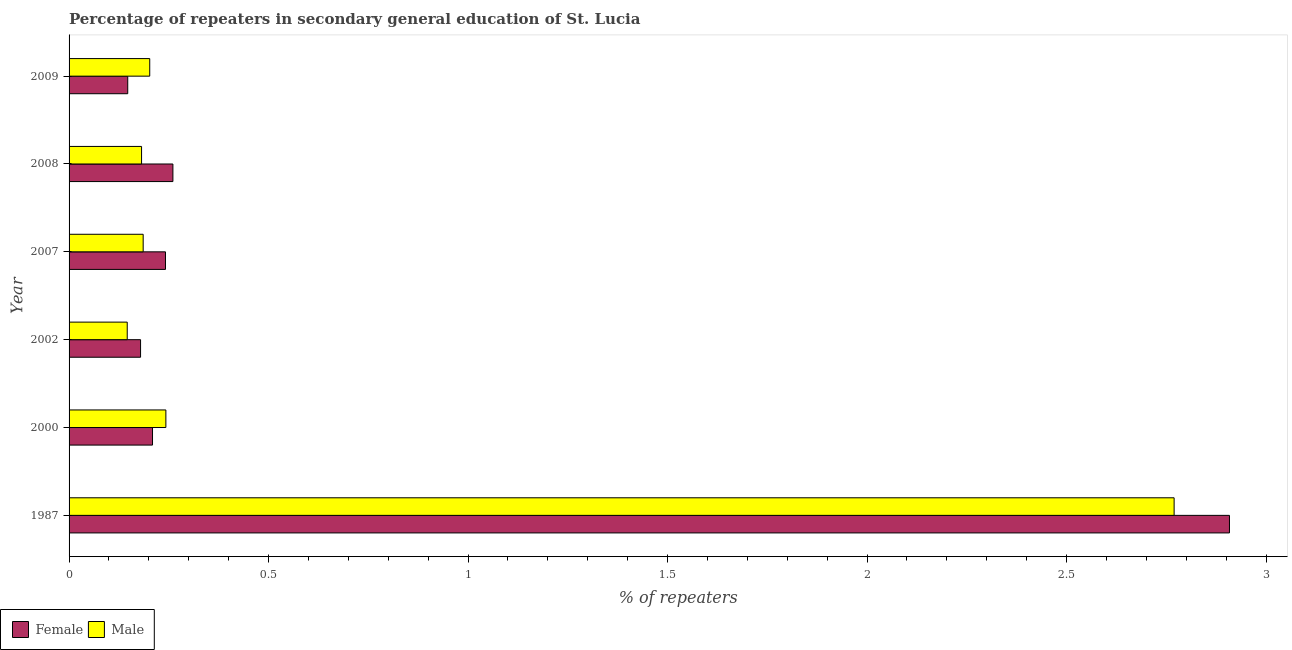How many bars are there on the 6th tick from the bottom?
Your answer should be very brief. 2. What is the percentage of female repeaters in 1987?
Your answer should be very brief. 2.91. Across all years, what is the maximum percentage of female repeaters?
Provide a short and direct response. 2.91. Across all years, what is the minimum percentage of male repeaters?
Offer a very short reply. 0.15. In which year was the percentage of female repeaters maximum?
Your response must be concise. 1987. What is the total percentage of male repeaters in the graph?
Your response must be concise. 3.73. What is the difference between the percentage of male repeaters in 1987 and that in 2000?
Provide a succinct answer. 2.53. What is the difference between the percentage of female repeaters in 2008 and the percentage of male repeaters in 2007?
Your answer should be compact. 0.07. What is the average percentage of male repeaters per year?
Give a very brief answer. 0.62. In the year 2002, what is the difference between the percentage of female repeaters and percentage of male repeaters?
Your response must be concise. 0.03. In how many years, is the percentage of male repeaters greater than 2.5 %?
Keep it short and to the point. 1. What is the ratio of the percentage of male repeaters in 1987 to that in 2007?
Ensure brevity in your answer.  14.91. Is the difference between the percentage of male repeaters in 2000 and 2002 greater than the difference between the percentage of female repeaters in 2000 and 2002?
Your response must be concise. Yes. What is the difference between the highest and the second highest percentage of male repeaters?
Offer a very short reply. 2.53. What is the difference between the highest and the lowest percentage of male repeaters?
Ensure brevity in your answer.  2.62. Is the sum of the percentage of female repeaters in 1987 and 2007 greater than the maximum percentage of male repeaters across all years?
Keep it short and to the point. Yes. What does the 2nd bar from the bottom in 2000 represents?
Your response must be concise. Male. Does the graph contain any zero values?
Give a very brief answer. No. Does the graph contain grids?
Your answer should be very brief. No. Where does the legend appear in the graph?
Make the answer very short. Bottom left. What is the title of the graph?
Your response must be concise. Percentage of repeaters in secondary general education of St. Lucia. Does "Ages 15-24" appear as one of the legend labels in the graph?
Provide a short and direct response. No. What is the label or title of the X-axis?
Your answer should be very brief. % of repeaters. What is the label or title of the Y-axis?
Make the answer very short. Year. What is the % of repeaters in Female in 1987?
Offer a very short reply. 2.91. What is the % of repeaters of Male in 1987?
Provide a succinct answer. 2.77. What is the % of repeaters of Female in 2000?
Provide a short and direct response. 0.21. What is the % of repeaters in Male in 2000?
Offer a terse response. 0.24. What is the % of repeaters of Female in 2002?
Make the answer very short. 0.18. What is the % of repeaters of Male in 2002?
Make the answer very short. 0.15. What is the % of repeaters in Female in 2007?
Provide a short and direct response. 0.24. What is the % of repeaters of Male in 2007?
Your answer should be very brief. 0.19. What is the % of repeaters of Female in 2008?
Your answer should be very brief. 0.26. What is the % of repeaters in Male in 2008?
Provide a succinct answer. 0.18. What is the % of repeaters in Female in 2009?
Offer a terse response. 0.15. What is the % of repeaters in Male in 2009?
Your response must be concise. 0.2. Across all years, what is the maximum % of repeaters of Female?
Your answer should be compact. 2.91. Across all years, what is the maximum % of repeaters in Male?
Provide a succinct answer. 2.77. Across all years, what is the minimum % of repeaters of Female?
Your response must be concise. 0.15. Across all years, what is the minimum % of repeaters of Male?
Keep it short and to the point. 0.15. What is the total % of repeaters of Female in the graph?
Your response must be concise. 3.95. What is the total % of repeaters of Male in the graph?
Give a very brief answer. 3.73. What is the difference between the % of repeaters in Female in 1987 and that in 2000?
Ensure brevity in your answer.  2.7. What is the difference between the % of repeaters of Male in 1987 and that in 2000?
Your response must be concise. 2.53. What is the difference between the % of repeaters in Female in 1987 and that in 2002?
Offer a very short reply. 2.73. What is the difference between the % of repeaters in Male in 1987 and that in 2002?
Offer a very short reply. 2.62. What is the difference between the % of repeaters of Female in 1987 and that in 2007?
Offer a terse response. 2.67. What is the difference between the % of repeaters in Male in 1987 and that in 2007?
Make the answer very short. 2.58. What is the difference between the % of repeaters in Female in 1987 and that in 2008?
Offer a terse response. 2.65. What is the difference between the % of repeaters of Male in 1987 and that in 2008?
Give a very brief answer. 2.59. What is the difference between the % of repeaters in Female in 1987 and that in 2009?
Make the answer very short. 2.76. What is the difference between the % of repeaters of Male in 1987 and that in 2009?
Provide a short and direct response. 2.57. What is the difference between the % of repeaters in Male in 2000 and that in 2002?
Give a very brief answer. 0.1. What is the difference between the % of repeaters in Female in 2000 and that in 2007?
Your answer should be very brief. -0.03. What is the difference between the % of repeaters of Male in 2000 and that in 2007?
Keep it short and to the point. 0.06. What is the difference between the % of repeaters of Female in 2000 and that in 2008?
Make the answer very short. -0.05. What is the difference between the % of repeaters of Male in 2000 and that in 2008?
Provide a short and direct response. 0.06. What is the difference between the % of repeaters of Female in 2000 and that in 2009?
Your response must be concise. 0.06. What is the difference between the % of repeaters in Male in 2000 and that in 2009?
Make the answer very short. 0.04. What is the difference between the % of repeaters of Female in 2002 and that in 2007?
Offer a very short reply. -0.06. What is the difference between the % of repeaters in Male in 2002 and that in 2007?
Your answer should be compact. -0.04. What is the difference between the % of repeaters in Female in 2002 and that in 2008?
Offer a terse response. -0.08. What is the difference between the % of repeaters in Male in 2002 and that in 2008?
Provide a short and direct response. -0.04. What is the difference between the % of repeaters in Female in 2002 and that in 2009?
Offer a terse response. 0.03. What is the difference between the % of repeaters of Male in 2002 and that in 2009?
Offer a terse response. -0.06. What is the difference between the % of repeaters of Female in 2007 and that in 2008?
Ensure brevity in your answer.  -0.02. What is the difference between the % of repeaters in Male in 2007 and that in 2008?
Offer a terse response. 0. What is the difference between the % of repeaters in Female in 2007 and that in 2009?
Provide a short and direct response. 0.09. What is the difference between the % of repeaters of Male in 2007 and that in 2009?
Your answer should be very brief. -0.02. What is the difference between the % of repeaters of Female in 2008 and that in 2009?
Offer a very short reply. 0.11. What is the difference between the % of repeaters in Male in 2008 and that in 2009?
Offer a terse response. -0.02. What is the difference between the % of repeaters of Female in 1987 and the % of repeaters of Male in 2000?
Provide a short and direct response. 2.67. What is the difference between the % of repeaters of Female in 1987 and the % of repeaters of Male in 2002?
Ensure brevity in your answer.  2.76. What is the difference between the % of repeaters of Female in 1987 and the % of repeaters of Male in 2007?
Offer a very short reply. 2.72. What is the difference between the % of repeaters in Female in 1987 and the % of repeaters in Male in 2008?
Make the answer very short. 2.73. What is the difference between the % of repeaters in Female in 1987 and the % of repeaters in Male in 2009?
Make the answer very short. 2.71. What is the difference between the % of repeaters of Female in 2000 and the % of repeaters of Male in 2002?
Provide a short and direct response. 0.06. What is the difference between the % of repeaters in Female in 2000 and the % of repeaters in Male in 2007?
Make the answer very short. 0.02. What is the difference between the % of repeaters in Female in 2000 and the % of repeaters in Male in 2008?
Provide a succinct answer. 0.03. What is the difference between the % of repeaters of Female in 2000 and the % of repeaters of Male in 2009?
Provide a succinct answer. 0.01. What is the difference between the % of repeaters in Female in 2002 and the % of repeaters in Male in 2007?
Keep it short and to the point. -0.01. What is the difference between the % of repeaters in Female in 2002 and the % of repeaters in Male in 2008?
Give a very brief answer. -0. What is the difference between the % of repeaters of Female in 2002 and the % of repeaters of Male in 2009?
Give a very brief answer. -0.02. What is the difference between the % of repeaters of Female in 2007 and the % of repeaters of Male in 2008?
Keep it short and to the point. 0.06. What is the difference between the % of repeaters in Female in 2007 and the % of repeaters in Male in 2009?
Give a very brief answer. 0.04. What is the difference between the % of repeaters of Female in 2008 and the % of repeaters of Male in 2009?
Offer a very short reply. 0.06. What is the average % of repeaters in Female per year?
Your answer should be compact. 0.66. What is the average % of repeaters in Male per year?
Provide a succinct answer. 0.62. In the year 1987, what is the difference between the % of repeaters of Female and % of repeaters of Male?
Make the answer very short. 0.14. In the year 2000, what is the difference between the % of repeaters in Female and % of repeaters in Male?
Provide a short and direct response. -0.03. In the year 2002, what is the difference between the % of repeaters of Female and % of repeaters of Male?
Give a very brief answer. 0.03. In the year 2007, what is the difference between the % of repeaters in Female and % of repeaters in Male?
Provide a short and direct response. 0.06. In the year 2008, what is the difference between the % of repeaters of Female and % of repeaters of Male?
Ensure brevity in your answer.  0.08. In the year 2009, what is the difference between the % of repeaters in Female and % of repeaters in Male?
Your answer should be compact. -0.06. What is the ratio of the % of repeaters in Female in 1987 to that in 2000?
Your answer should be compact. 13.91. What is the ratio of the % of repeaters of Male in 1987 to that in 2000?
Your response must be concise. 11.42. What is the ratio of the % of repeaters in Female in 1987 to that in 2002?
Provide a short and direct response. 16.23. What is the ratio of the % of repeaters in Male in 1987 to that in 2002?
Provide a short and direct response. 19. What is the ratio of the % of repeaters of Female in 1987 to that in 2007?
Ensure brevity in your answer.  12.04. What is the ratio of the % of repeaters of Male in 1987 to that in 2007?
Your response must be concise. 14.91. What is the ratio of the % of repeaters of Female in 1987 to that in 2008?
Your response must be concise. 11.18. What is the ratio of the % of repeaters in Male in 1987 to that in 2008?
Your answer should be very brief. 15.24. What is the ratio of the % of repeaters of Female in 1987 to that in 2009?
Provide a succinct answer. 19.78. What is the ratio of the % of repeaters in Male in 1987 to that in 2009?
Your answer should be compact. 13.7. What is the ratio of the % of repeaters of Female in 2000 to that in 2002?
Provide a succinct answer. 1.17. What is the ratio of the % of repeaters in Male in 2000 to that in 2002?
Your response must be concise. 1.66. What is the ratio of the % of repeaters in Female in 2000 to that in 2007?
Your answer should be compact. 0.87. What is the ratio of the % of repeaters of Male in 2000 to that in 2007?
Offer a terse response. 1.31. What is the ratio of the % of repeaters in Female in 2000 to that in 2008?
Provide a short and direct response. 0.8. What is the ratio of the % of repeaters of Male in 2000 to that in 2008?
Offer a very short reply. 1.34. What is the ratio of the % of repeaters in Female in 2000 to that in 2009?
Your response must be concise. 1.42. What is the ratio of the % of repeaters in Male in 2000 to that in 2009?
Offer a terse response. 1.2. What is the ratio of the % of repeaters in Female in 2002 to that in 2007?
Your response must be concise. 0.74. What is the ratio of the % of repeaters of Male in 2002 to that in 2007?
Make the answer very short. 0.78. What is the ratio of the % of repeaters in Female in 2002 to that in 2008?
Offer a very short reply. 0.69. What is the ratio of the % of repeaters in Male in 2002 to that in 2008?
Provide a short and direct response. 0.8. What is the ratio of the % of repeaters of Female in 2002 to that in 2009?
Provide a short and direct response. 1.22. What is the ratio of the % of repeaters of Male in 2002 to that in 2009?
Keep it short and to the point. 0.72. What is the ratio of the % of repeaters of Female in 2007 to that in 2008?
Your answer should be very brief. 0.93. What is the ratio of the % of repeaters in Male in 2007 to that in 2008?
Provide a succinct answer. 1.02. What is the ratio of the % of repeaters in Female in 2007 to that in 2009?
Give a very brief answer. 1.64. What is the ratio of the % of repeaters in Male in 2007 to that in 2009?
Provide a succinct answer. 0.92. What is the ratio of the % of repeaters of Female in 2008 to that in 2009?
Provide a short and direct response. 1.77. What is the ratio of the % of repeaters of Male in 2008 to that in 2009?
Make the answer very short. 0.9. What is the difference between the highest and the second highest % of repeaters in Female?
Keep it short and to the point. 2.65. What is the difference between the highest and the second highest % of repeaters of Male?
Offer a terse response. 2.53. What is the difference between the highest and the lowest % of repeaters of Female?
Offer a terse response. 2.76. What is the difference between the highest and the lowest % of repeaters of Male?
Your answer should be compact. 2.62. 